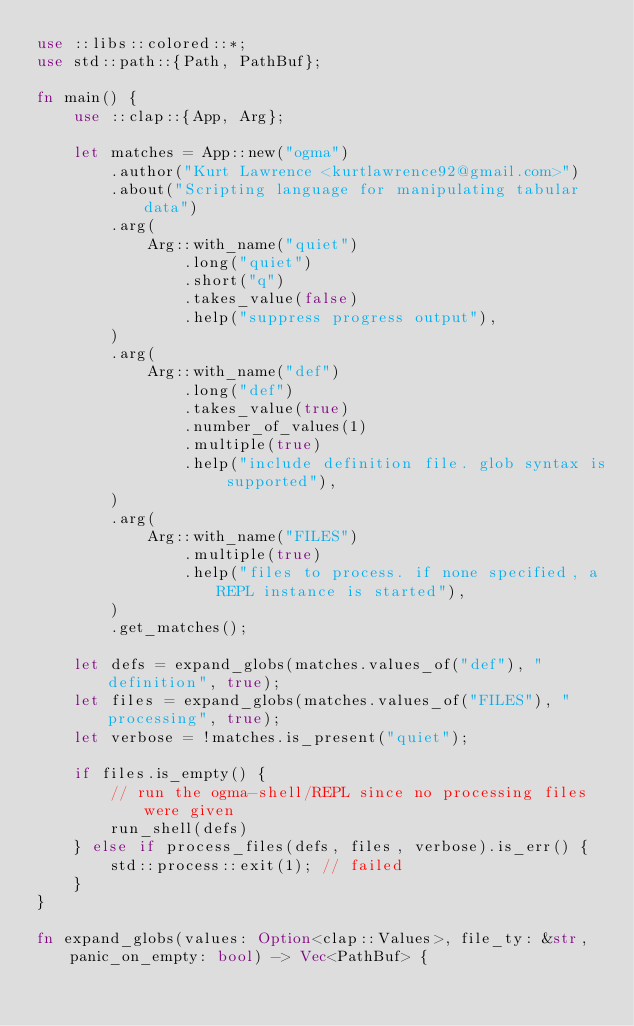<code> <loc_0><loc_0><loc_500><loc_500><_Rust_>use ::libs::colored::*;
use std::path::{Path, PathBuf};

fn main() {
    use ::clap::{App, Arg};

    let matches = App::new("ogma")
        .author("Kurt Lawrence <kurtlawrence92@gmail.com>")
        .about("Scripting language for manipulating tabular data")
        .arg(
            Arg::with_name("quiet")
                .long("quiet")
                .short("q")
                .takes_value(false)
                .help("suppress progress output"),
        )
        .arg(
            Arg::with_name("def")
                .long("def")
                .takes_value(true)
                .number_of_values(1)
                .multiple(true)
                .help("include definition file. glob syntax is supported"),
        )
        .arg(
            Arg::with_name("FILES")
                .multiple(true)
                .help("files to process. if none specified, a REPL instance is started"),
        )
        .get_matches();

    let defs = expand_globs(matches.values_of("def"), "definition", true);
    let files = expand_globs(matches.values_of("FILES"), "processing", true);
    let verbose = !matches.is_present("quiet");

    if files.is_empty() {
        // run the ogma-shell/REPL since no processing files were given
        run_shell(defs)
    } else if process_files(defs, files, verbose).is_err() {
        std::process::exit(1); // failed
    }
}

fn expand_globs(values: Option<clap::Values>, file_ty: &str, panic_on_empty: bool) -> Vec<PathBuf> {</code> 